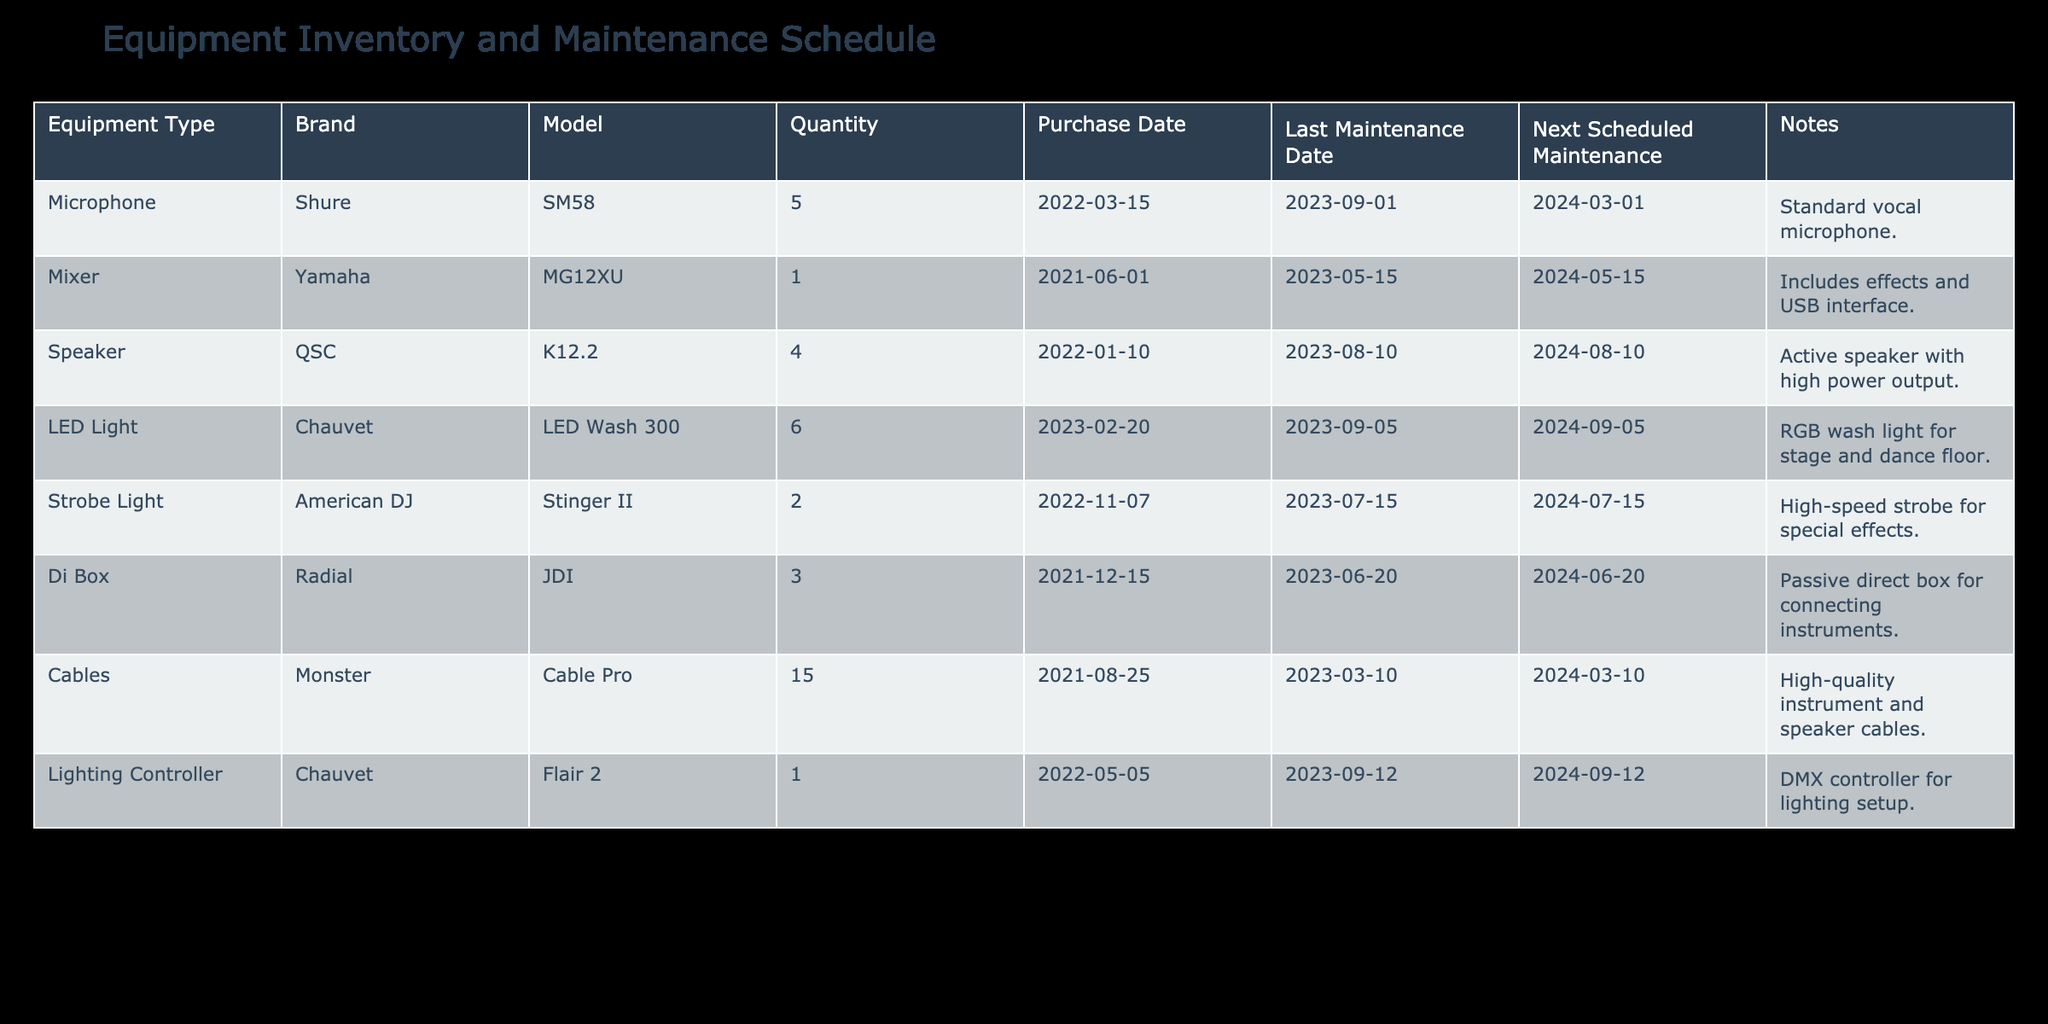What's the total quantity of microphones listed? The table shows that there are five microphones listed under the "Quantity" column for the Shure SM58 model. Therefore, the total quantity of microphones is 5.
Answer: 5 What is the next scheduled maintenance date for the QSC K12.2 speakers? The next scheduled maintenance date for the QSC K12.2 speakers can be found in the "Next Scheduled Maintenance" column, which indicates the date as 2024-08-10.
Answer: 2024-08-10 How many types of lighting equipment are listed in the inventory? The lighting equipment types listed in the table are LED Light and Strobe Light, totaling two distinct types.
Answer: 2 What is the difference in purchase dates between the Mixer and the Di Box? The purchase date for the Mixer (Yamaha MG12XU) is 2021-06-01 and for the Di Box (Radial JDI) is 2021-12-15. The difference in years and months is 6 months.
Answer: 6 months Are there any pieces of equipment that have over four units in stock? Looking at the "Quantity" column, the highest amount listed is 15 cables, confirming that there is equipment (Cables) that has over four units in stock.
Answer: Yes What's the average quantity of sound equipment (Microphones, Mixers, Speakers, and Di Boxes) in the inventory? The total quantity of sound equipment includes 5 microphones, 1 mixer, 4 speakers, and 3 di boxes. Summing these gives 5 + 1 + 4 + 3 = 13. Dividing by the number of equipment types (4) gives an average of 13 / 4 = 3.25.
Answer: 3.25 Which piece of equipment was last maintained most recently, and when was it last maintained? By looking at the "Last Maintenance Date" column, the LED Wash 300 was last maintained on 2023-09-05, which is the most recent date in the inventory.
Answer: LED Wash 300, 2023-09-05 Is there any equipment scheduled for maintenance within the next month? Evaluating the "Next Scheduled Maintenance" column, the next upcoming date is 2024-03-01 for Microphones, which is not within the next month. Thus, there is no equipment scheduled for maintenance within the next month.
Answer: No What is the total count of all equipment types listed in the inventory? To find the total count, we sum up the quantities: 5 (Microphones) + 1 (Mixer) + 4 (Speakers) + 6 (LED Lights) + 2 (Strobe Lights) + 3 (Di Boxes) + 15 (Cables) + 1 (Lighting Controller) = 37.
Answer: 37 